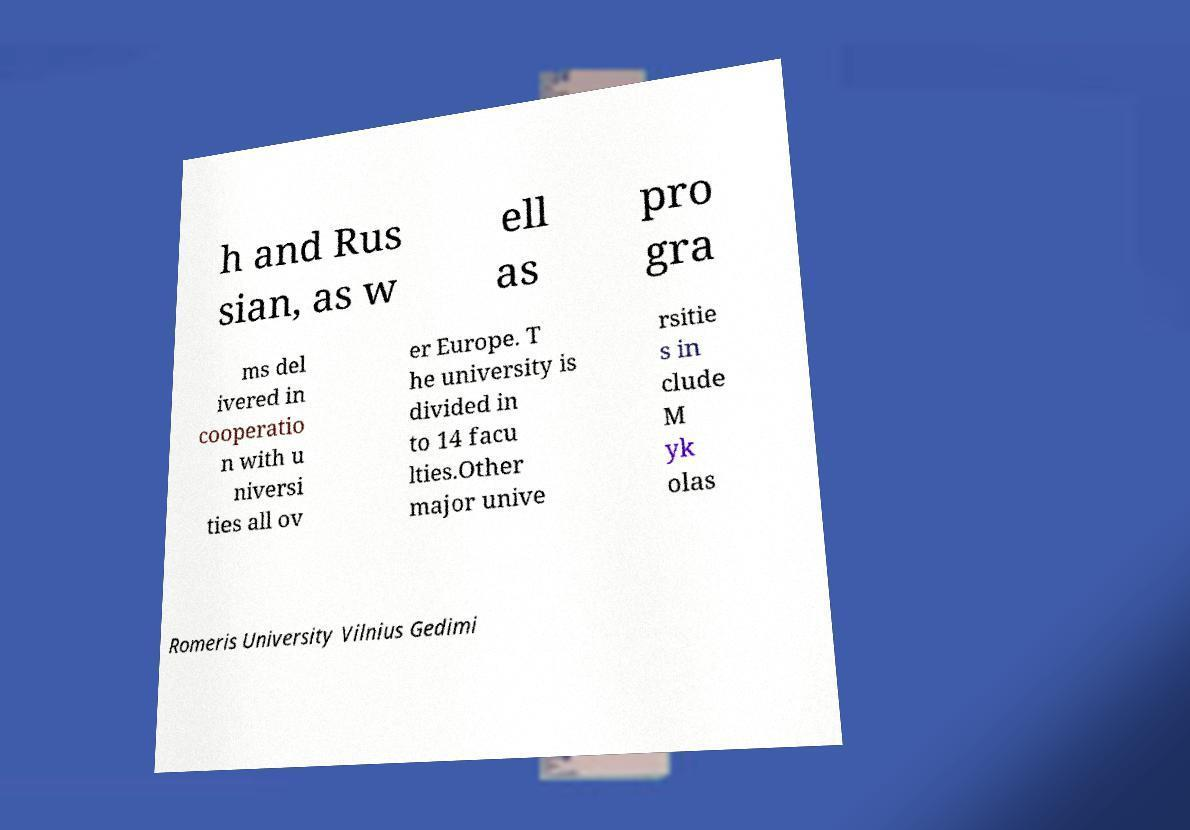Please identify and transcribe the text found in this image. h and Rus sian, as w ell as pro gra ms del ivered in cooperatio n with u niversi ties all ov er Europe. T he university is divided in to 14 facu lties.Other major unive rsitie s in clude M yk olas Romeris University Vilnius Gedimi 